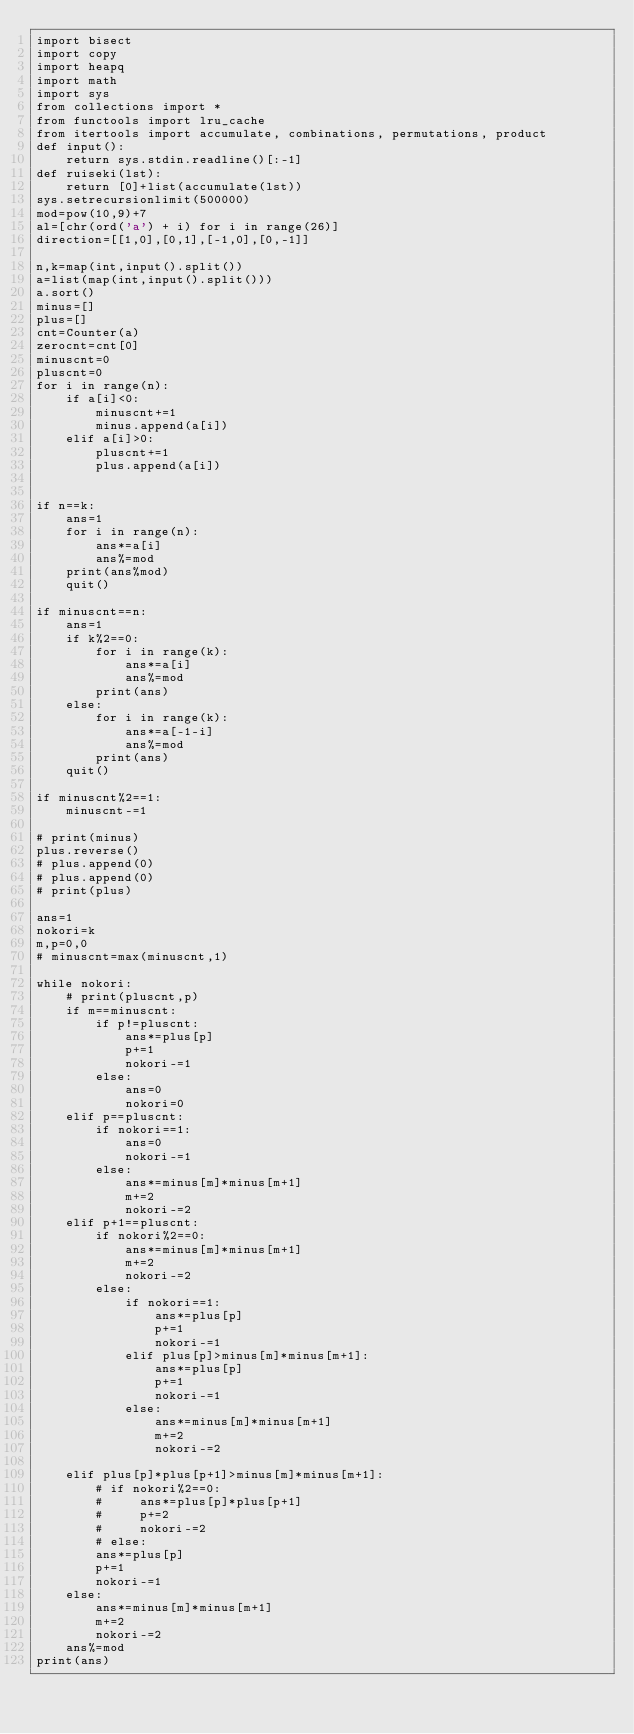Convert code to text. <code><loc_0><loc_0><loc_500><loc_500><_Python_>import bisect
import copy
import heapq
import math
import sys
from collections import *
from functools import lru_cache
from itertools import accumulate, combinations, permutations, product
def input():
    return sys.stdin.readline()[:-1]
def ruiseki(lst):
    return [0]+list(accumulate(lst))
sys.setrecursionlimit(500000)
mod=pow(10,9)+7
al=[chr(ord('a') + i) for i in range(26)]
direction=[[1,0],[0,1],[-1,0],[0,-1]]

n,k=map(int,input().split())
a=list(map(int,input().split()))
a.sort()
minus=[]
plus=[]
cnt=Counter(a)
zerocnt=cnt[0]
minuscnt=0
pluscnt=0
for i in range(n):
    if a[i]<0:
        minuscnt+=1
        minus.append(a[i])
    elif a[i]>0:
        pluscnt+=1
        plus.append(a[i])


if n==k:
    ans=1
    for i in range(n):
        ans*=a[i]
        ans%=mod
    print(ans%mod)
    quit()

if minuscnt==n:
    ans=1
    if k%2==0:
        for i in range(k):
            ans*=a[i]
            ans%=mod
        print(ans)
    else:
        for i in range(k):
            ans*=a[-1-i]
            ans%=mod
        print(ans)
    quit()

if minuscnt%2==1:
    minuscnt-=1

# print(minus)
plus.reverse()
# plus.append(0)
# plus.append(0)
# print(plus)

ans=1
nokori=k
m,p=0,0
# minuscnt=max(minuscnt,1)

while nokori:
    # print(pluscnt,p)
    if m==minuscnt:
        if p!=pluscnt:
            ans*=plus[p]
            p+=1
            nokori-=1
        else:
            ans=0
            nokori=0
    elif p==pluscnt:
        if nokori==1:
            ans=0
            nokori-=1
        else:
            ans*=minus[m]*minus[m+1]
            m+=2
            nokori-=2
    elif p+1==pluscnt:
        if nokori%2==0:
            ans*=minus[m]*minus[m+1]
            m+=2
            nokori-=2
        else:
            if nokori==1:
                ans*=plus[p]
                p+=1
                nokori-=1
            elif plus[p]>minus[m]*minus[m+1]:
                ans*=plus[p]
                p+=1
                nokori-=1
            else:
                ans*=minus[m]*minus[m+1]
                m+=2
                nokori-=2

    elif plus[p]*plus[p+1]>minus[m]*minus[m+1]:
        # if nokori%2==0:
        #     ans*=plus[p]*plus[p+1]
        #     p+=2
        #     nokori-=2
        # else:
        ans*=plus[p]
        p+=1
        nokori-=1
    else:
        ans*=minus[m]*minus[m+1]
        m+=2
        nokori-=2
    ans%=mod
print(ans)</code> 